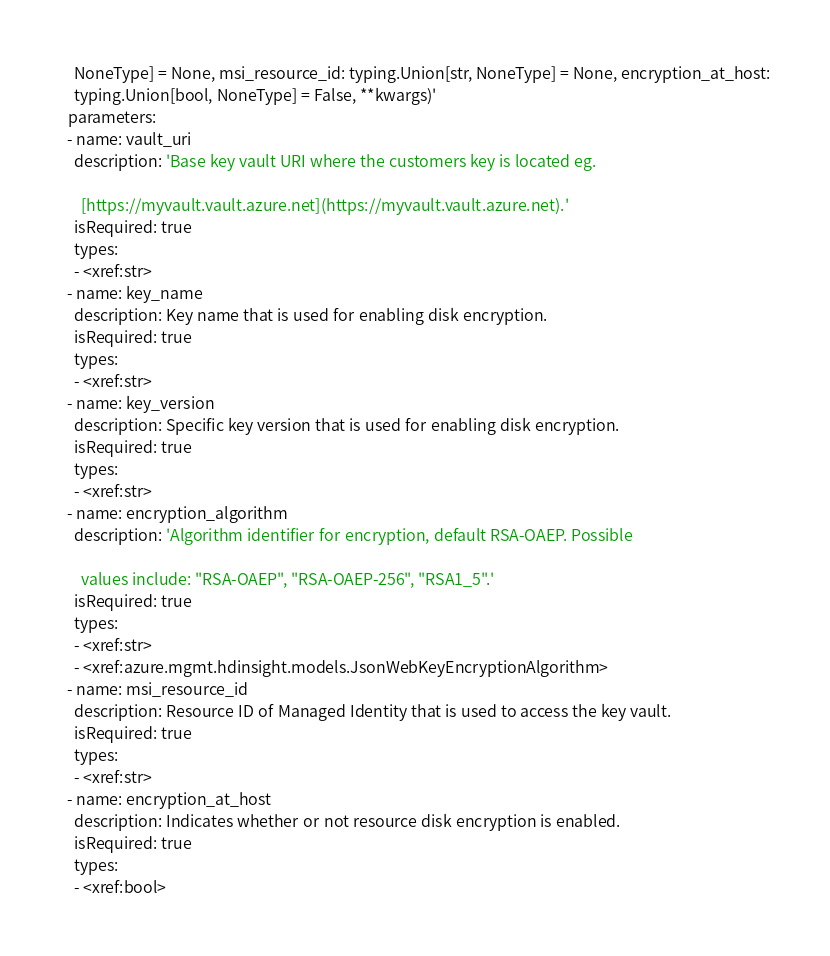<code> <loc_0><loc_0><loc_500><loc_500><_YAML_>    NoneType] = None, msi_resource_id: typing.Union[str, NoneType] = None, encryption_at_host:
    typing.Union[bool, NoneType] = False, **kwargs)'
  parameters:
  - name: vault_uri
    description: 'Base key vault URI where the customers key is located eg.

      [https://myvault.vault.azure.net](https://myvault.vault.azure.net).'
    isRequired: true
    types:
    - <xref:str>
  - name: key_name
    description: Key name that is used for enabling disk encryption.
    isRequired: true
    types:
    - <xref:str>
  - name: key_version
    description: Specific key version that is used for enabling disk encryption.
    isRequired: true
    types:
    - <xref:str>
  - name: encryption_algorithm
    description: 'Algorithm identifier for encryption, default RSA-OAEP. Possible

      values include: "RSA-OAEP", "RSA-OAEP-256", "RSA1_5".'
    isRequired: true
    types:
    - <xref:str>
    - <xref:azure.mgmt.hdinsight.models.JsonWebKeyEncryptionAlgorithm>
  - name: msi_resource_id
    description: Resource ID of Managed Identity that is used to access the key vault.
    isRequired: true
    types:
    - <xref:str>
  - name: encryption_at_host
    description: Indicates whether or not resource disk encryption is enabled.
    isRequired: true
    types:
    - <xref:bool>
</code> 